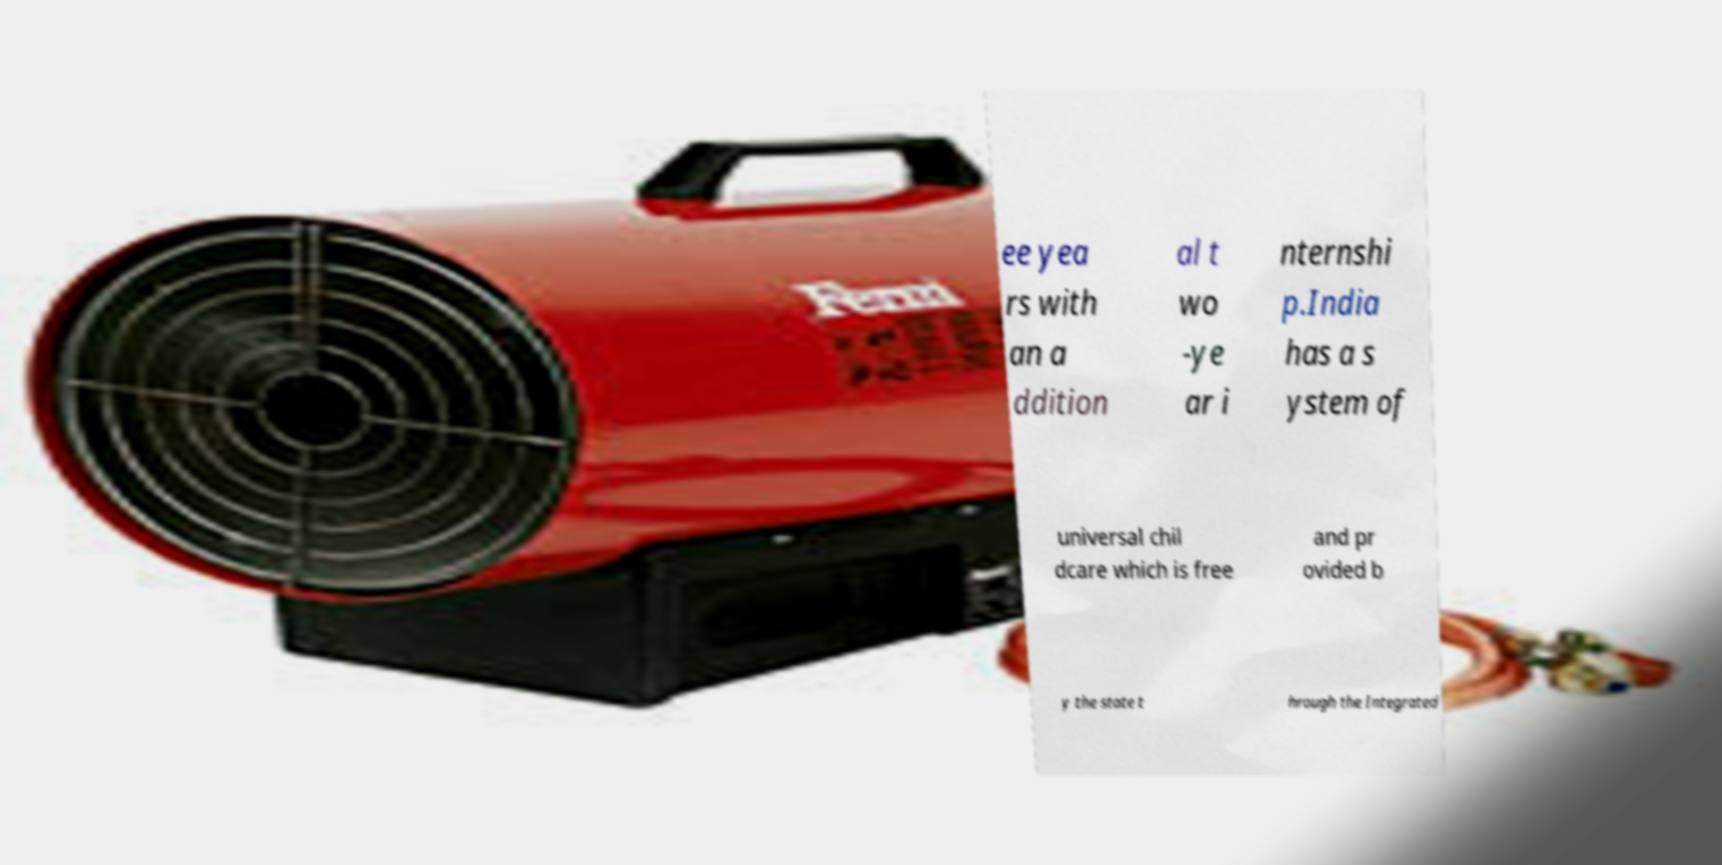Can you read and provide the text displayed in the image?This photo seems to have some interesting text. Can you extract and type it out for me? ee yea rs with an a ddition al t wo -ye ar i nternshi p.India has a s ystem of universal chil dcare which is free and pr ovided b y the state t hrough the Integrated 